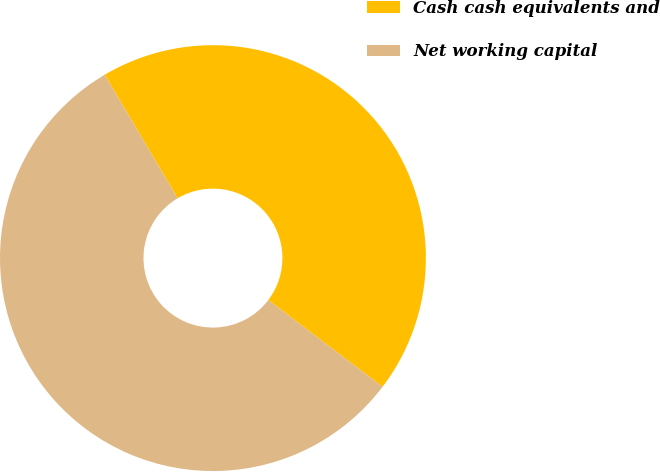<chart> <loc_0><loc_0><loc_500><loc_500><pie_chart><fcel>Cash cash equivalents and<fcel>Net working capital<nl><fcel>43.82%<fcel>56.18%<nl></chart> 